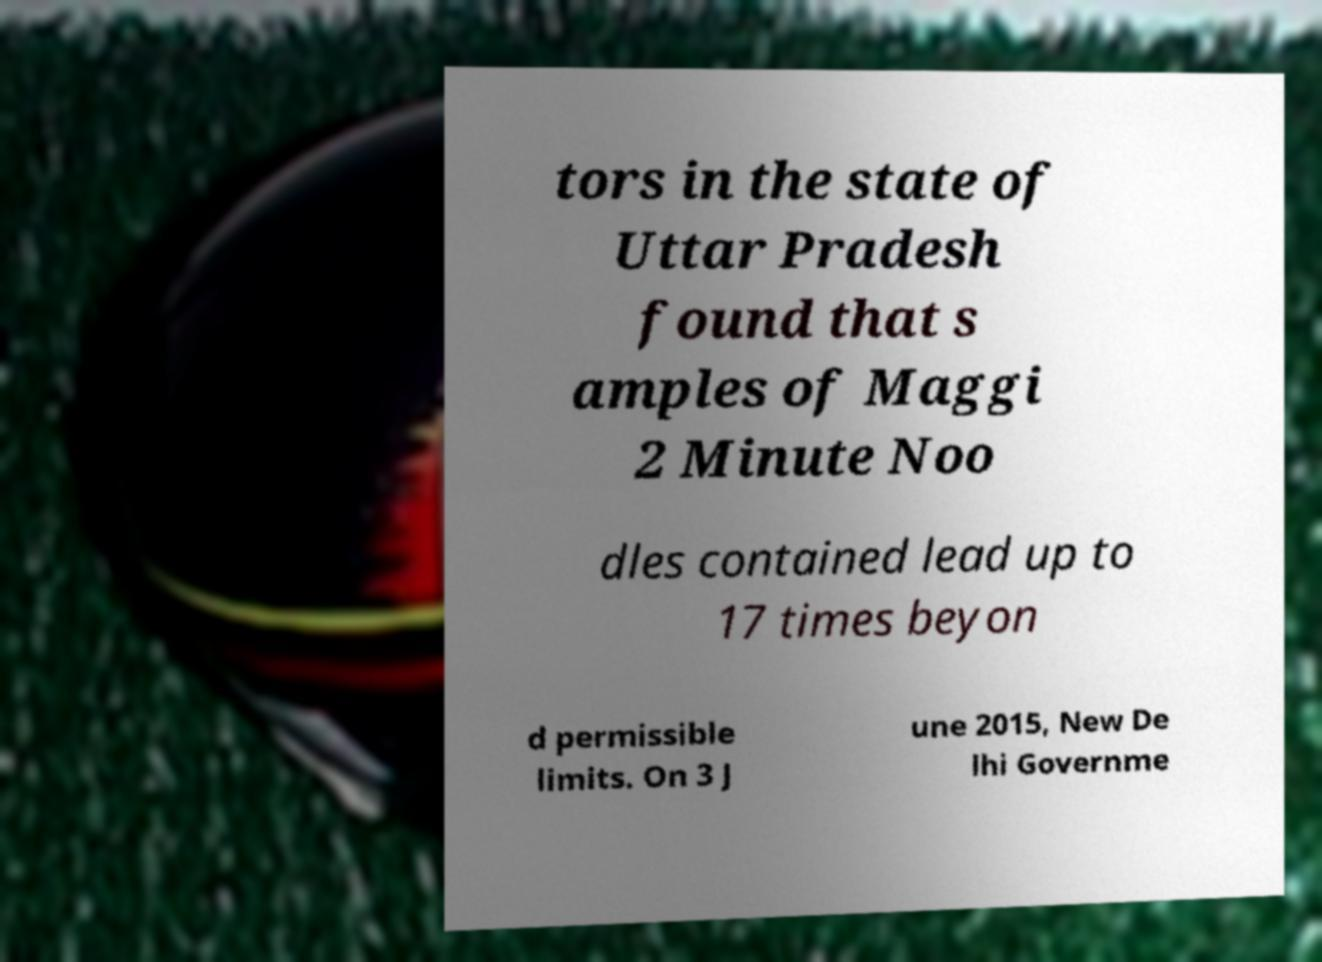I need the written content from this picture converted into text. Can you do that? tors in the state of Uttar Pradesh found that s amples of Maggi 2 Minute Noo dles contained lead up to 17 times beyon d permissible limits. On 3 J une 2015, New De lhi Governme 